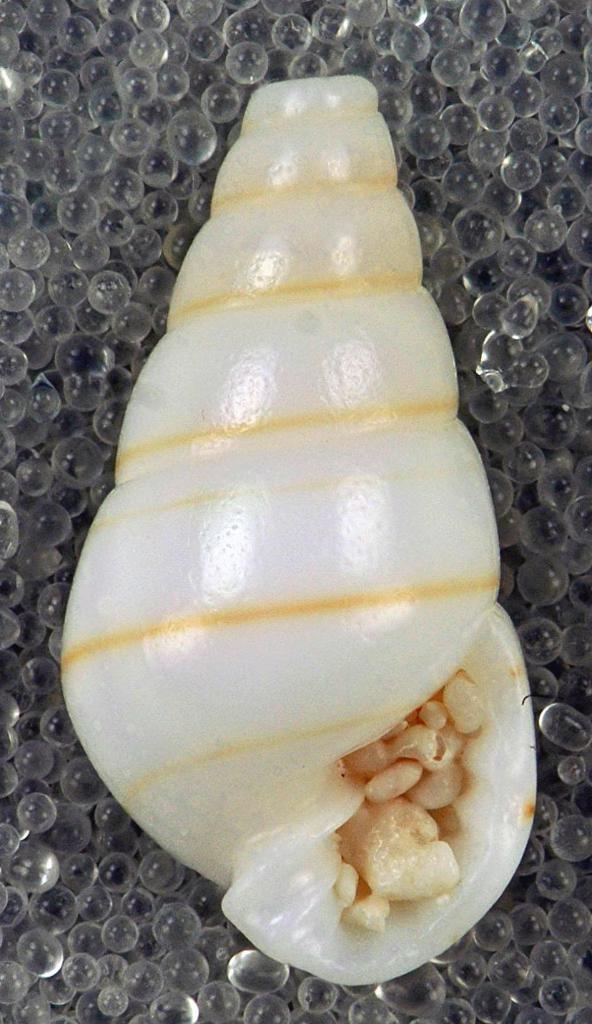In one or two sentences, can you explain what this image depicts? In this picture we can see sea shell on water balls. 